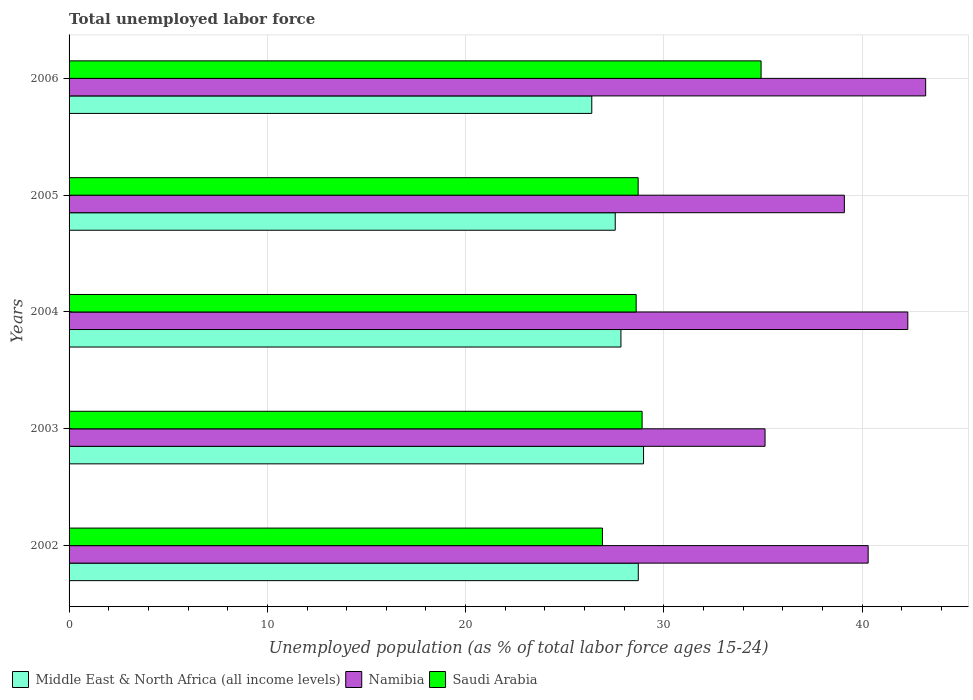How many different coloured bars are there?
Provide a succinct answer. 3. How many groups of bars are there?
Offer a very short reply. 5. How many bars are there on the 5th tick from the top?
Your answer should be compact. 3. In how many cases, is the number of bars for a given year not equal to the number of legend labels?
Give a very brief answer. 0. What is the percentage of unemployed population in in Namibia in 2004?
Offer a very short reply. 42.3. Across all years, what is the maximum percentage of unemployed population in in Middle East & North Africa (all income levels)?
Provide a succinct answer. 28.97. Across all years, what is the minimum percentage of unemployed population in in Middle East & North Africa (all income levels)?
Provide a short and direct response. 26.36. In which year was the percentage of unemployed population in in Middle East & North Africa (all income levels) minimum?
Your answer should be compact. 2006. What is the total percentage of unemployed population in in Saudi Arabia in the graph?
Provide a succinct answer. 148. What is the difference between the percentage of unemployed population in in Middle East & North Africa (all income levels) in 2002 and that in 2004?
Make the answer very short. 0.87. What is the difference between the percentage of unemployed population in in Namibia in 2006 and the percentage of unemployed population in in Middle East & North Africa (all income levels) in 2003?
Offer a very short reply. 14.23. What is the average percentage of unemployed population in in Saudi Arabia per year?
Your answer should be very brief. 29.6. In the year 2006, what is the difference between the percentage of unemployed population in in Namibia and percentage of unemployed population in in Saudi Arabia?
Your answer should be very brief. 8.3. In how many years, is the percentage of unemployed population in in Namibia greater than 36 %?
Give a very brief answer. 4. What is the ratio of the percentage of unemployed population in in Namibia in 2002 to that in 2005?
Keep it short and to the point. 1.03. Is the percentage of unemployed population in in Saudi Arabia in 2004 less than that in 2006?
Make the answer very short. Yes. Is the difference between the percentage of unemployed population in in Namibia in 2004 and 2005 greater than the difference between the percentage of unemployed population in in Saudi Arabia in 2004 and 2005?
Keep it short and to the point. Yes. What is the difference between the highest and the second highest percentage of unemployed population in in Saudi Arabia?
Provide a succinct answer. 6. What is the difference between the highest and the lowest percentage of unemployed population in in Namibia?
Offer a very short reply. 8.1. In how many years, is the percentage of unemployed population in in Saudi Arabia greater than the average percentage of unemployed population in in Saudi Arabia taken over all years?
Keep it short and to the point. 1. What does the 3rd bar from the top in 2005 represents?
Your answer should be very brief. Middle East & North Africa (all income levels). What does the 2nd bar from the bottom in 2006 represents?
Your response must be concise. Namibia. How many bars are there?
Provide a succinct answer. 15. Are all the bars in the graph horizontal?
Give a very brief answer. Yes. Does the graph contain grids?
Your response must be concise. Yes. How many legend labels are there?
Offer a very short reply. 3. What is the title of the graph?
Ensure brevity in your answer.  Total unemployed labor force. Does "American Samoa" appear as one of the legend labels in the graph?
Offer a very short reply. No. What is the label or title of the X-axis?
Provide a succinct answer. Unemployed population (as % of total labor force ages 15-24). What is the label or title of the Y-axis?
Ensure brevity in your answer.  Years. What is the Unemployed population (as % of total labor force ages 15-24) in Middle East & North Africa (all income levels) in 2002?
Your answer should be very brief. 28.71. What is the Unemployed population (as % of total labor force ages 15-24) of Namibia in 2002?
Provide a short and direct response. 40.3. What is the Unemployed population (as % of total labor force ages 15-24) of Saudi Arabia in 2002?
Offer a terse response. 26.9. What is the Unemployed population (as % of total labor force ages 15-24) of Middle East & North Africa (all income levels) in 2003?
Keep it short and to the point. 28.97. What is the Unemployed population (as % of total labor force ages 15-24) in Namibia in 2003?
Your answer should be very brief. 35.1. What is the Unemployed population (as % of total labor force ages 15-24) in Saudi Arabia in 2003?
Provide a succinct answer. 28.9. What is the Unemployed population (as % of total labor force ages 15-24) of Middle East & North Africa (all income levels) in 2004?
Your answer should be very brief. 27.83. What is the Unemployed population (as % of total labor force ages 15-24) in Namibia in 2004?
Keep it short and to the point. 42.3. What is the Unemployed population (as % of total labor force ages 15-24) of Saudi Arabia in 2004?
Make the answer very short. 28.6. What is the Unemployed population (as % of total labor force ages 15-24) in Middle East & North Africa (all income levels) in 2005?
Your response must be concise. 27.54. What is the Unemployed population (as % of total labor force ages 15-24) of Namibia in 2005?
Your answer should be compact. 39.1. What is the Unemployed population (as % of total labor force ages 15-24) of Saudi Arabia in 2005?
Provide a short and direct response. 28.7. What is the Unemployed population (as % of total labor force ages 15-24) in Middle East & North Africa (all income levels) in 2006?
Your response must be concise. 26.36. What is the Unemployed population (as % of total labor force ages 15-24) of Namibia in 2006?
Offer a very short reply. 43.2. What is the Unemployed population (as % of total labor force ages 15-24) in Saudi Arabia in 2006?
Your answer should be very brief. 34.9. Across all years, what is the maximum Unemployed population (as % of total labor force ages 15-24) of Middle East & North Africa (all income levels)?
Provide a short and direct response. 28.97. Across all years, what is the maximum Unemployed population (as % of total labor force ages 15-24) of Namibia?
Provide a short and direct response. 43.2. Across all years, what is the maximum Unemployed population (as % of total labor force ages 15-24) in Saudi Arabia?
Provide a short and direct response. 34.9. Across all years, what is the minimum Unemployed population (as % of total labor force ages 15-24) in Middle East & North Africa (all income levels)?
Give a very brief answer. 26.36. Across all years, what is the minimum Unemployed population (as % of total labor force ages 15-24) of Namibia?
Ensure brevity in your answer.  35.1. Across all years, what is the minimum Unemployed population (as % of total labor force ages 15-24) of Saudi Arabia?
Offer a terse response. 26.9. What is the total Unemployed population (as % of total labor force ages 15-24) in Middle East & North Africa (all income levels) in the graph?
Provide a short and direct response. 139.42. What is the total Unemployed population (as % of total labor force ages 15-24) in Namibia in the graph?
Keep it short and to the point. 200. What is the total Unemployed population (as % of total labor force ages 15-24) in Saudi Arabia in the graph?
Your answer should be compact. 148. What is the difference between the Unemployed population (as % of total labor force ages 15-24) of Middle East & North Africa (all income levels) in 2002 and that in 2003?
Your answer should be very brief. -0.27. What is the difference between the Unemployed population (as % of total labor force ages 15-24) in Middle East & North Africa (all income levels) in 2002 and that in 2004?
Offer a terse response. 0.87. What is the difference between the Unemployed population (as % of total labor force ages 15-24) of Saudi Arabia in 2002 and that in 2004?
Your answer should be compact. -1.7. What is the difference between the Unemployed population (as % of total labor force ages 15-24) of Middle East & North Africa (all income levels) in 2002 and that in 2005?
Provide a short and direct response. 1.16. What is the difference between the Unemployed population (as % of total labor force ages 15-24) in Middle East & North Africa (all income levels) in 2002 and that in 2006?
Make the answer very short. 2.35. What is the difference between the Unemployed population (as % of total labor force ages 15-24) of Namibia in 2002 and that in 2006?
Make the answer very short. -2.9. What is the difference between the Unemployed population (as % of total labor force ages 15-24) of Saudi Arabia in 2002 and that in 2006?
Provide a short and direct response. -8. What is the difference between the Unemployed population (as % of total labor force ages 15-24) in Middle East & North Africa (all income levels) in 2003 and that in 2004?
Make the answer very short. 1.14. What is the difference between the Unemployed population (as % of total labor force ages 15-24) of Saudi Arabia in 2003 and that in 2004?
Ensure brevity in your answer.  0.3. What is the difference between the Unemployed population (as % of total labor force ages 15-24) of Middle East & North Africa (all income levels) in 2003 and that in 2005?
Offer a very short reply. 1.43. What is the difference between the Unemployed population (as % of total labor force ages 15-24) in Namibia in 2003 and that in 2005?
Provide a short and direct response. -4. What is the difference between the Unemployed population (as % of total labor force ages 15-24) in Middle East & North Africa (all income levels) in 2003 and that in 2006?
Ensure brevity in your answer.  2.61. What is the difference between the Unemployed population (as % of total labor force ages 15-24) of Namibia in 2003 and that in 2006?
Keep it short and to the point. -8.1. What is the difference between the Unemployed population (as % of total labor force ages 15-24) in Middle East & North Africa (all income levels) in 2004 and that in 2005?
Ensure brevity in your answer.  0.29. What is the difference between the Unemployed population (as % of total labor force ages 15-24) in Saudi Arabia in 2004 and that in 2005?
Offer a terse response. -0.1. What is the difference between the Unemployed population (as % of total labor force ages 15-24) in Middle East & North Africa (all income levels) in 2004 and that in 2006?
Provide a succinct answer. 1.47. What is the difference between the Unemployed population (as % of total labor force ages 15-24) of Namibia in 2004 and that in 2006?
Keep it short and to the point. -0.9. What is the difference between the Unemployed population (as % of total labor force ages 15-24) of Middle East & North Africa (all income levels) in 2005 and that in 2006?
Keep it short and to the point. 1.18. What is the difference between the Unemployed population (as % of total labor force ages 15-24) in Saudi Arabia in 2005 and that in 2006?
Make the answer very short. -6.2. What is the difference between the Unemployed population (as % of total labor force ages 15-24) of Middle East & North Africa (all income levels) in 2002 and the Unemployed population (as % of total labor force ages 15-24) of Namibia in 2003?
Give a very brief answer. -6.39. What is the difference between the Unemployed population (as % of total labor force ages 15-24) in Middle East & North Africa (all income levels) in 2002 and the Unemployed population (as % of total labor force ages 15-24) in Saudi Arabia in 2003?
Provide a short and direct response. -0.19. What is the difference between the Unemployed population (as % of total labor force ages 15-24) of Namibia in 2002 and the Unemployed population (as % of total labor force ages 15-24) of Saudi Arabia in 2003?
Make the answer very short. 11.4. What is the difference between the Unemployed population (as % of total labor force ages 15-24) in Middle East & North Africa (all income levels) in 2002 and the Unemployed population (as % of total labor force ages 15-24) in Namibia in 2004?
Provide a succinct answer. -13.59. What is the difference between the Unemployed population (as % of total labor force ages 15-24) of Middle East & North Africa (all income levels) in 2002 and the Unemployed population (as % of total labor force ages 15-24) of Saudi Arabia in 2004?
Provide a short and direct response. 0.11. What is the difference between the Unemployed population (as % of total labor force ages 15-24) in Namibia in 2002 and the Unemployed population (as % of total labor force ages 15-24) in Saudi Arabia in 2004?
Your answer should be compact. 11.7. What is the difference between the Unemployed population (as % of total labor force ages 15-24) of Middle East & North Africa (all income levels) in 2002 and the Unemployed population (as % of total labor force ages 15-24) of Namibia in 2005?
Provide a succinct answer. -10.39. What is the difference between the Unemployed population (as % of total labor force ages 15-24) of Middle East & North Africa (all income levels) in 2002 and the Unemployed population (as % of total labor force ages 15-24) of Saudi Arabia in 2005?
Ensure brevity in your answer.  0.01. What is the difference between the Unemployed population (as % of total labor force ages 15-24) of Middle East & North Africa (all income levels) in 2002 and the Unemployed population (as % of total labor force ages 15-24) of Namibia in 2006?
Your answer should be very brief. -14.49. What is the difference between the Unemployed population (as % of total labor force ages 15-24) of Middle East & North Africa (all income levels) in 2002 and the Unemployed population (as % of total labor force ages 15-24) of Saudi Arabia in 2006?
Your answer should be very brief. -6.19. What is the difference between the Unemployed population (as % of total labor force ages 15-24) of Middle East & North Africa (all income levels) in 2003 and the Unemployed population (as % of total labor force ages 15-24) of Namibia in 2004?
Your answer should be compact. -13.33. What is the difference between the Unemployed population (as % of total labor force ages 15-24) in Middle East & North Africa (all income levels) in 2003 and the Unemployed population (as % of total labor force ages 15-24) in Saudi Arabia in 2004?
Offer a very short reply. 0.37. What is the difference between the Unemployed population (as % of total labor force ages 15-24) in Namibia in 2003 and the Unemployed population (as % of total labor force ages 15-24) in Saudi Arabia in 2004?
Give a very brief answer. 6.5. What is the difference between the Unemployed population (as % of total labor force ages 15-24) in Middle East & North Africa (all income levels) in 2003 and the Unemployed population (as % of total labor force ages 15-24) in Namibia in 2005?
Offer a very short reply. -10.13. What is the difference between the Unemployed population (as % of total labor force ages 15-24) in Middle East & North Africa (all income levels) in 2003 and the Unemployed population (as % of total labor force ages 15-24) in Saudi Arabia in 2005?
Provide a succinct answer. 0.27. What is the difference between the Unemployed population (as % of total labor force ages 15-24) of Namibia in 2003 and the Unemployed population (as % of total labor force ages 15-24) of Saudi Arabia in 2005?
Your response must be concise. 6.4. What is the difference between the Unemployed population (as % of total labor force ages 15-24) in Middle East & North Africa (all income levels) in 2003 and the Unemployed population (as % of total labor force ages 15-24) in Namibia in 2006?
Your answer should be compact. -14.23. What is the difference between the Unemployed population (as % of total labor force ages 15-24) in Middle East & North Africa (all income levels) in 2003 and the Unemployed population (as % of total labor force ages 15-24) in Saudi Arabia in 2006?
Make the answer very short. -5.93. What is the difference between the Unemployed population (as % of total labor force ages 15-24) of Middle East & North Africa (all income levels) in 2004 and the Unemployed population (as % of total labor force ages 15-24) of Namibia in 2005?
Provide a succinct answer. -11.27. What is the difference between the Unemployed population (as % of total labor force ages 15-24) in Middle East & North Africa (all income levels) in 2004 and the Unemployed population (as % of total labor force ages 15-24) in Saudi Arabia in 2005?
Give a very brief answer. -0.87. What is the difference between the Unemployed population (as % of total labor force ages 15-24) in Namibia in 2004 and the Unemployed population (as % of total labor force ages 15-24) in Saudi Arabia in 2005?
Make the answer very short. 13.6. What is the difference between the Unemployed population (as % of total labor force ages 15-24) of Middle East & North Africa (all income levels) in 2004 and the Unemployed population (as % of total labor force ages 15-24) of Namibia in 2006?
Offer a very short reply. -15.37. What is the difference between the Unemployed population (as % of total labor force ages 15-24) in Middle East & North Africa (all income levels) in 2004 and the Unemployed population (as % of total labor force ages 15-24) in Saudi Arabia in 2006?
Your answer should be very brief. -7.07. What is the difference between the Unemployed population (as % of total labor force ages 15-24) of Middle East & North Africa (all income levels) in 2005 and the Unemployed population (as % of total labor force ages 15-24) of Namibia in 2006?
Offer a terse response. -15.66. What is the difference between the Unemployed population (as % of total labor force ages 15-24) in Middle East & North Africa (all income levels) in 2005 and the Unemployed population (as % of total labor force ages 15-24) in Saudi Arabia in 2006?
Ensure brevity in your answer.  -7.36. What is the average Unemployed population (as % of total labor force ages 15-24) of Middle East & North Africa (all income levels) per year?
Give a very brief answer. 27.88. What is the average Unemployed population (as % of total labor force ages 15-24) in Saudi Arabia per year?
Give a very brief answer. 29.6. In the year 2002, what is the difference between the Unemployed population (as % of total labor force ages 15-24) of Middle East & North Africa (all income levels) and Unemployed population (as % of total labor force ages 15-24) of Namibia?
Give a very brief answer. -11.59. In the year 2002, what is the difference between the Unemployed population (as % of total labor force ages 15-24) in Middle East & North Africa (all income levels) and Unemployed population (as % of total labor force ages 15-24) in Saudi Arabia?
Offer a very short reply. 1.81. In the year 2002, what is the difference between the Unemployed population (as % of total labor force ages 15-24) in Namibia and Unemployed population (as % of total labor force ages 15-24) in Saudi Arabia?
Provide a succinct answer. 13.4. In the year 2003, what is the difference between the Unemployed population (as % of total labor force ages 15-24) of Middle East & North Africa (all income levels) and Unemployed population (as % of total labor force ages 15-24) of Namibia?
Ensure brevity in your answer.  -6.13. In the year 2003, what is the difference between the Unemployed population (as % of total labor force ages 15-24) of Middle East & North Africa (all income levels) and Unemployed population (as % of total labor force ages 15-24) of Saudi Arabia?
Offer a terse response. 0.07. In the year 2003, what is the difference between the Unemployed population (as % of total labor force ages 15-24) in Namibia and Unemployed population (as % of total labor force ages 15-24) in Saudi Arabia?
Offer a terse response. 6.2. In the year 2004, what is the difference between the Unemployed population (as % of total labor force ages 15-24) of Middle East & North Africa (all income levels) and Unemployed population (as % of total labor force ages 15-24) of Namibia?
Your answer should be very brief. -14.47. In the year 2004, what is the difference between the Unemployed population (as % of total labor force ages 15-24) in Middle East & North Africa (all income levels) and Unemployed population (as % of total labor force ages 15-24) in Saudi Arabia?
Your answer should be very brief. -0.77. In the year 2005, what is the difference between the Unemployed population (as % of total labor force ages 15-24) in Middle East & North Africa (all income levels) and Unemployed population (as % of total labor force ages 15-24) in Namibia?
Make the answer very short. -11.56. In the year 2005, what is the difference between the Unemployed population (as % of total labor force ages 15-24) of Middle East & North Africa (all income levels) and Unemployed population (as % of total labor force ages 15-24) of Saudi Arabia?
Offer a very short reply. -1.16. In the year 2005, what is the difference between the Unemployed population (as % of total labor force ages 15-24) in Namibia and Unemployed population (as % of total labor force ages 15-24) in Saudi Arabia?
Offer a terse response. 10.4. In the year 2006, what is the difference between the Unemployed population (as % of total labor force ages 15-24) in Middle East & North Africa (all income levels) and Unemployed population (as % of total labor force ages 15-24) in Namibia?
Give a very brief answer. -16.84. In the year 2006, what is the difference between the Unemployed population (as % of total labor force ages 15-24) of Middle East & North Africa (all income levels) and Unemployed population (as % of total labor force ages 15-24) of Saudi Arabia?
Your answer should be very brief. -8.54. In the year 2006, what is the difference between the Unemployed population (as % of total labor force ages 15-24) in Namibia and Unemployed population (as % of total labor force ages 15-24) in Saudi Arabia?
Offer a very short reply. 8.3. What is the ratio of the Unemployed population (as % of total labor force ages 15-24) in Middle East & North Africa (all income levels) in 2002 to that in 2003?
Provide a short and direct response. 0.99. What is the ratio of the Unemployed population (as % of total labor force ages 15-24) of Namibia in 2002 to that in 2003?
Provide a short and direct response. 1.15. What is the ratio of the Unemployed population (as % of total labor force ages 15-24) in Saudi Arabia in 2002 to that in 2003?
Provide a succinct answer. 0.93. What is the ratio of the Unemployed population (as % of total labor force ages 15-24) in Middle East & North Africa (all income levels) in 2002 to that in 2004?
Your answer should be very brief. 1.03. What is the ratio of the Unemployed population (as % of total labor force ages 15-24) in Namibia in 2002 to that in 2004?
Provide a succinct answer. 0.95. What is the ratio of the Unemployed population (as % of total labor force ages 15-24) of Saudi Arabia in 2002 to that in 2004?
Keep it short and to the point. 0.94. What is the ratio of the Unemployed population (as % of total labor force ages 15-24) of Middle East & North Africa (all income levels) in 2002 to that in 2005?
Provide a short and direct response. 1.04. What is the ratio of the Unemployed population (as % of total labor force ages 15-24) of Namibia in 2002 to that in 2005?
Your answer should be very brief. 1.03. What is the ratio of the Unemployed population (as % of total labor force ages 15-24) of Saudi Arabia in 2002 to that in 2005?
Provide a short and direct response. 0.94. What is the ratio of the Unemployed population (as % of total labor force ages 15-24) in Middle East & North Africa (all income levels) in 2002 to that in 2006?
Your answer should be compact. 1.09. What is the ratio of the Unemployed population (as % of total labor force ages 15-24) in Namibia in 2002 to that in 2006?
Offer a terse response. 0.93. What is the ratio of the Unemployed population (as % of total labor force ages 15-24) in Saudi Arabia in 2002 to that in 2006?
Provide a succinct answer. 0.77. What is the ratio of the Unemployed population (as % of total labor force ages 15-24) in Middle East & North Africa (all income levels) in 2003 to that in 2004?
Offer a very short reply. 1.04. What is the ratio of the Unemployed population (as % of total labor force ages 15-24) in Namibia in 2003 to that in 2004?
Make the answer very short. 0.83. What is the ratio of the Unemployed population (as % of total labor force ages 15-24) in Saudi Arabia in 2003 to that in 2004?
Offer a very short reply. 1.01. What is the ratio of the Unemployed population (as % of total labor force ages 15-24) in Middle East & North Africa (all income levels) in 2003 to that in 2005?
Offer a very short reply. 1.05. What is the ratio of the Unemployed population (as % of total labor force ages 15-24) in Namibia in 2003 to that in 2005?
Provide a short and direct response. 0.9. What is the ratio of the Unemployed population (as % of total labor force ages 15-24) in Middle East & North Africa (all income levels) in 2003 to that in 2006?
Your answer should be compact. 1.1. What is the ratio of the Unemployed population (as % of total labor force ages 15-24) of Namibia in 2003 to that in 2006?
Your answer should be compact. 0.81. What is the ratio of the Unemployed population (as % of total labor force ages 15-24) in Saudi Arabia in 2003 to that in 2006?
Keep it short and to the point. 0.83. What is the ratio of the Unemployed population (as % of total labor force ages 15-24) in Middle East & North Africa (all income levels) in 2004 to that in 2005?
Offer a very short reply. 1.01. What is the ratio of the Unemployed population (as % of total labor force ages 15-24) of Namibia in 2004 to that in 2005?
Keep it short and to the point. 1.08. What is the ratio of the Unemployed population (as % of total labor force ages 15-24) in Middle East & North Africa (all income levels) in 2004 to that in 2006?
Ensure brevity in your answer.  1.06. What is the ratio of the Unemployed population (as % of total labor force ages 15-24) of Namibia in 2004 to that in 2006?
Your answer should be compact. 0.98. What is the ratio of the Unemployed population (as % of total labor force ages 15-24) in Saudi Arabia in 2004 to that in 2006?
Offer a very short reply. 0.82. What is the ratio of the Unemployed population (as % of total labor force ages 15-24) in Middle East & North Africa (all income levels) in 2005 to that in 2006?
Give a very brief answer. 1.04. What is the ratio of the Unemployed population (as % of total labor force ages 15-24) in Namibia in 2005 to that in 2006?
Give a very brief answer. 0.91. What is the ratio of the Unemployed population (as % of total labor force ages 15-24) of Saudi Arabia in 2005 to that in 2006?
Your response must be concise. 0.82. What is the difference between the highest and the second highest Unemployed population (as % of total labor force ages 15-24) of Middle East & North Africa (all income levels)?
Make the answer very short. 0.27. What is the difference between the highest and the second highest Unemployed population (as % of total labor force ages 15-24) in Saudi Arabia?
Offer a terse response. 6. What is the difference between the highest and the lowest Unemployed population (as % of total labor force ages 15-24) in Middle East & North Africa (all income levels)?
Give a very brief answer. 2.61. 